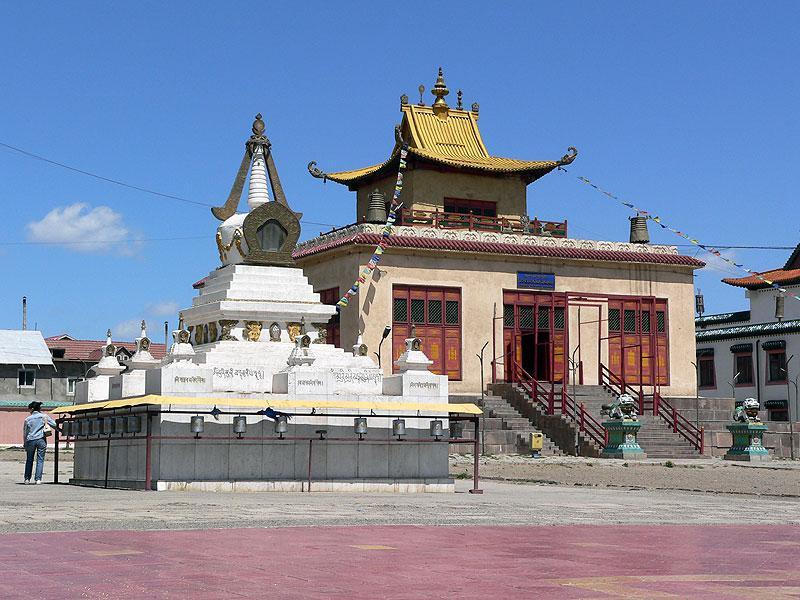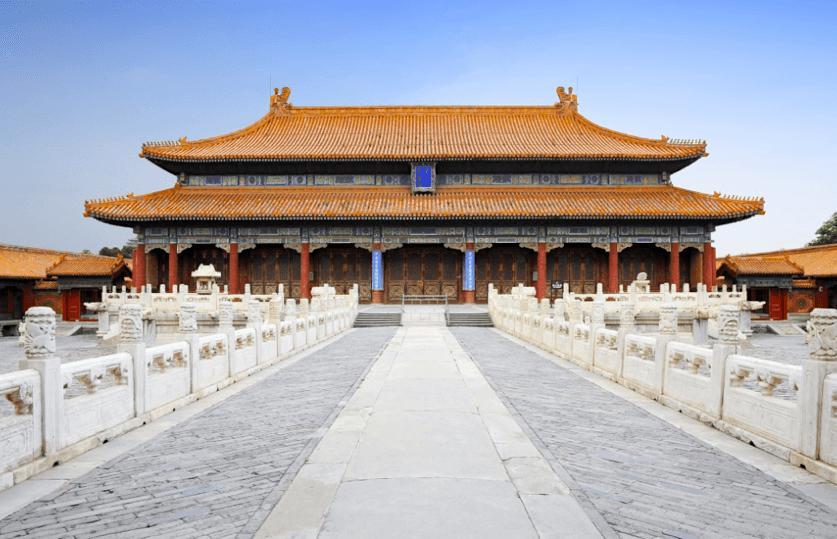The first image is the image on the left, the second image is the image on the right. Analyze the images presented: Is the assertion "In one image, the roof features green shapes topped with crosses." valid? Answer yes or no. No. The first image is the image on the left, the second image is the image on the right. Given the left and right images, does the statement "There is a cross atop the building in the image on the left." hold true? Answer yes or no. No. 